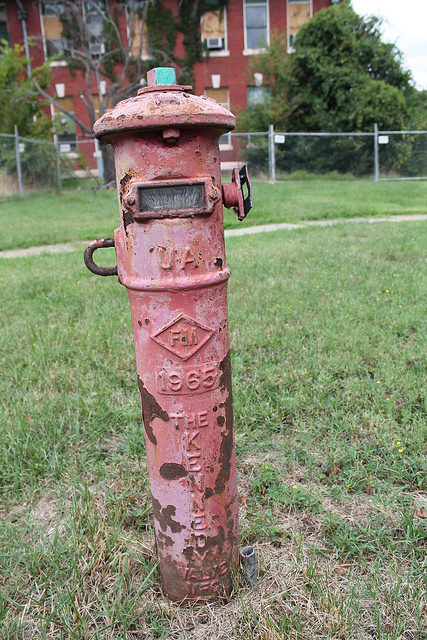Read all the text in this image. UA 1965 THE KENNEDY VALYS YES 